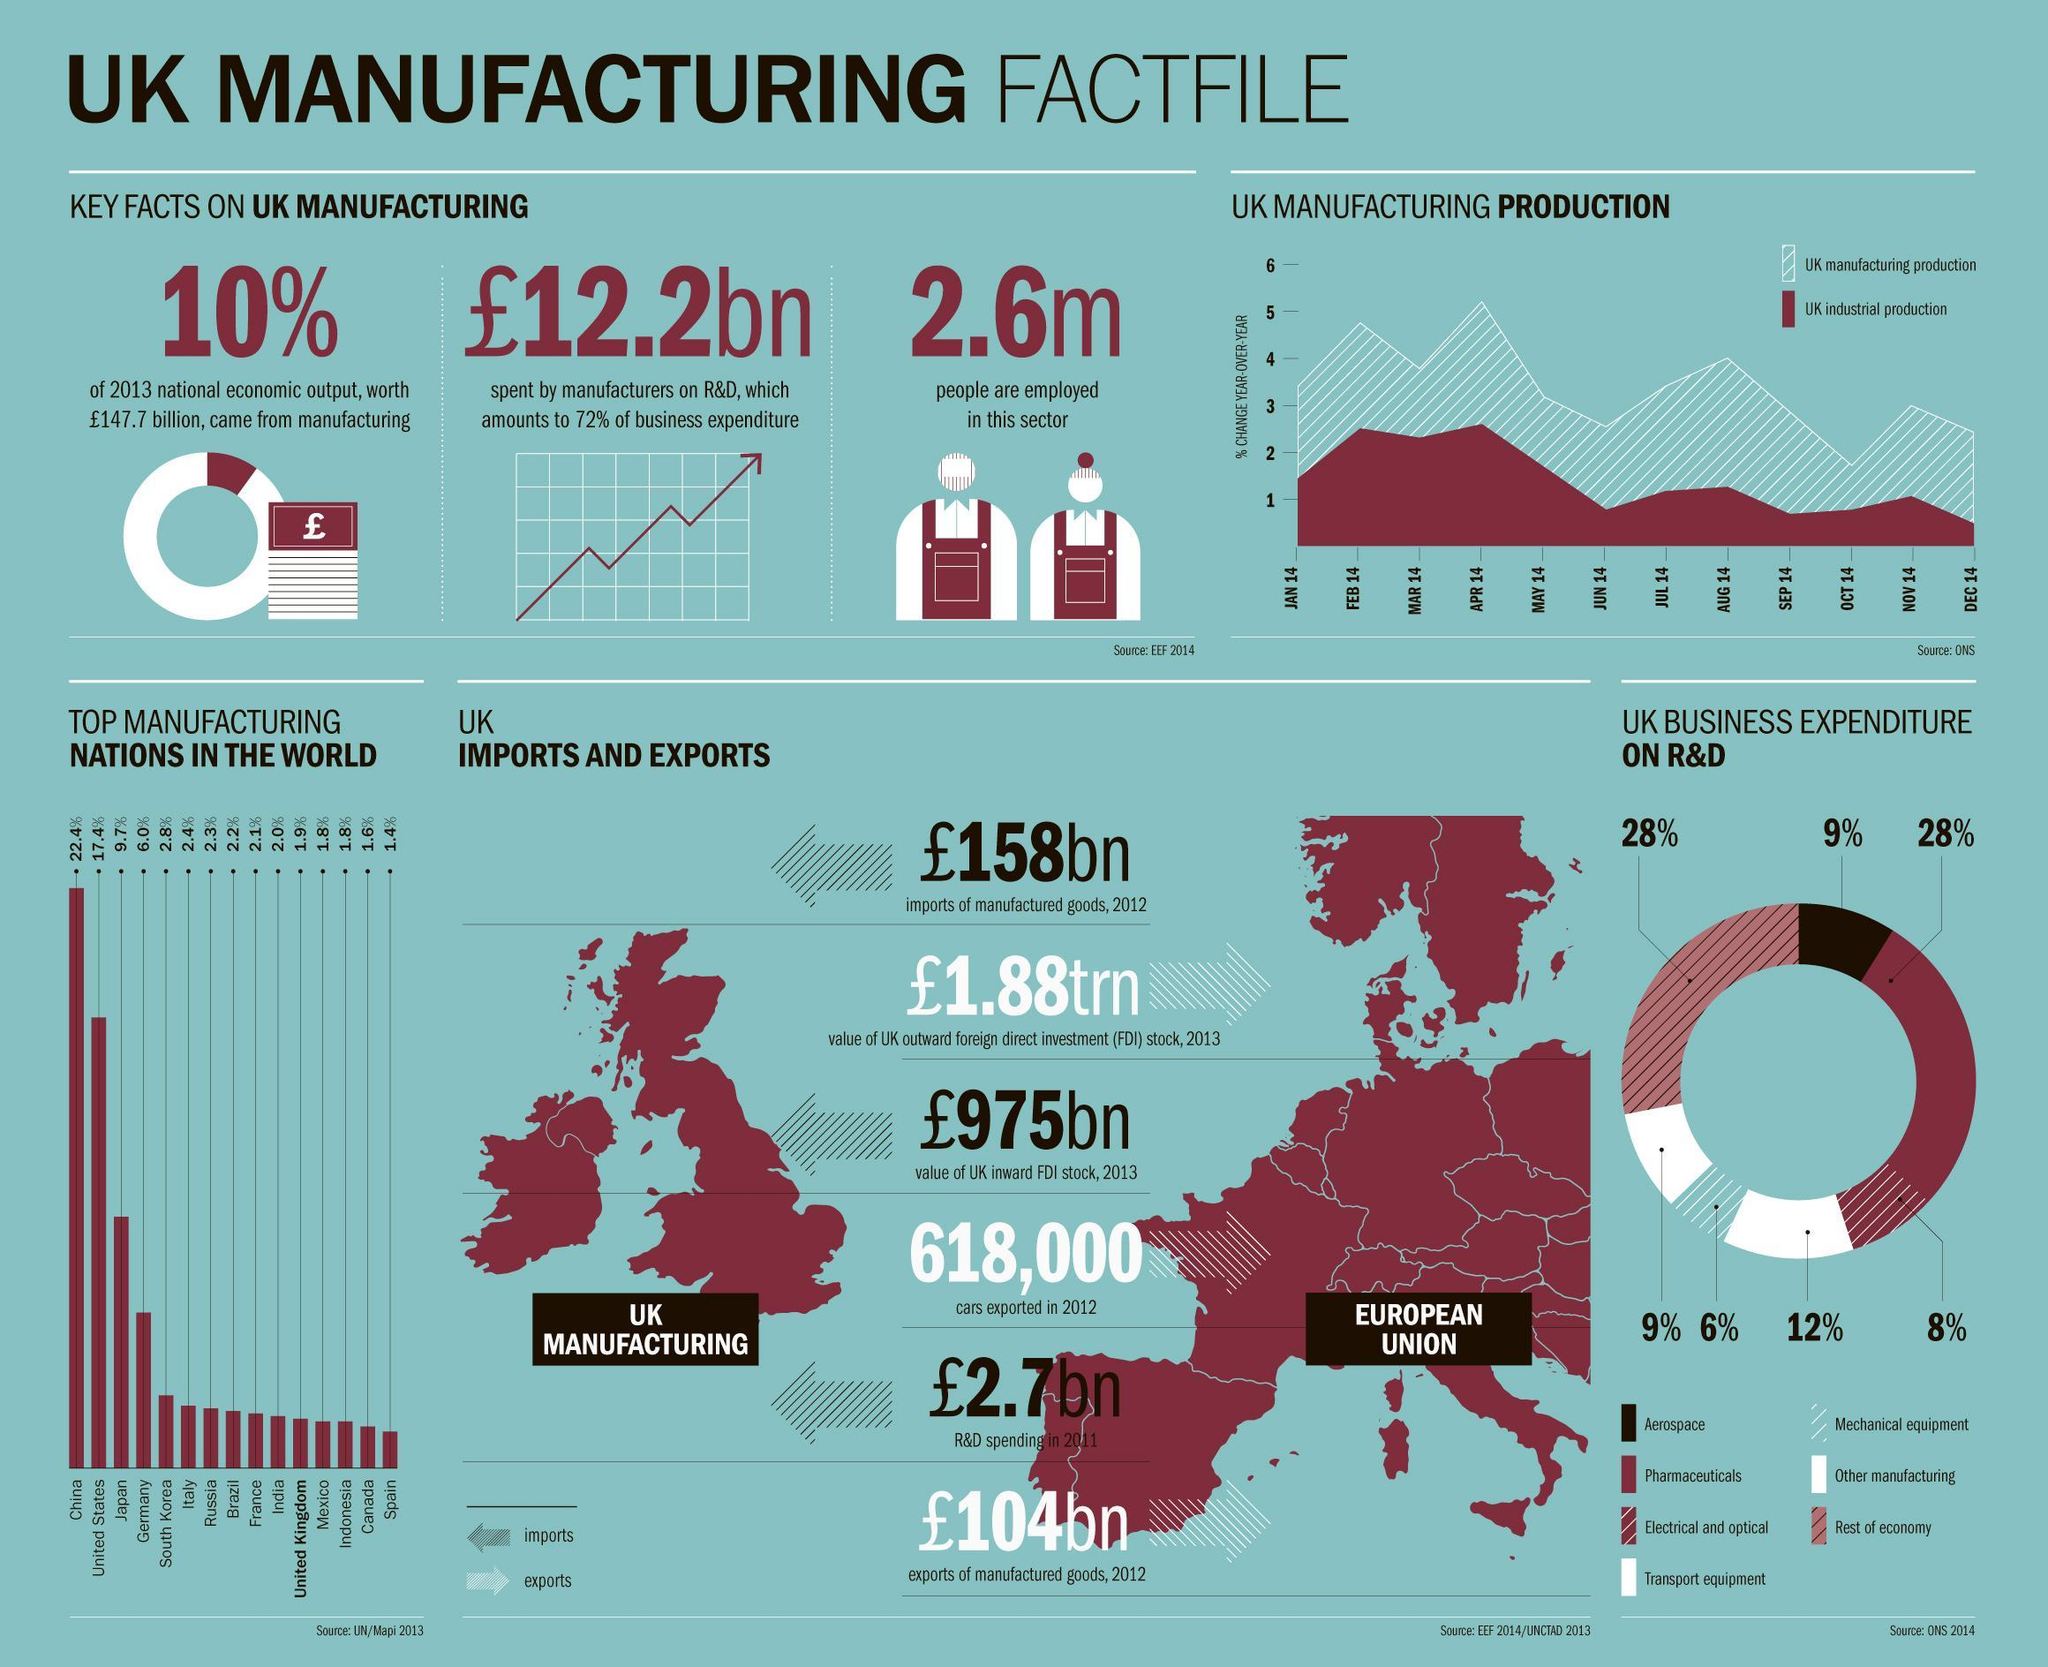What is the percentage of UK business expenditure on Mechanical equipment R&D in 2014?
Answer the question with a short phrase. 6% What is the export value of manufactured goods in UK in 2012? £104bn Which is the top manufacturing nation in the world in 2013? China What is the percentage of UK business expenditure on Pharmaceuticals R&D in 2014? 28% What percentage of 2013 national economic output in UK came from manufacturing? 10% What is the percentage of UK business expenditure on Aerospace R&D in 2014? 9% What is the population of employees in UK manufacturing sector in 2013? 2.6m What is the import value of UK inward FDI stock in 2013? £975bn 